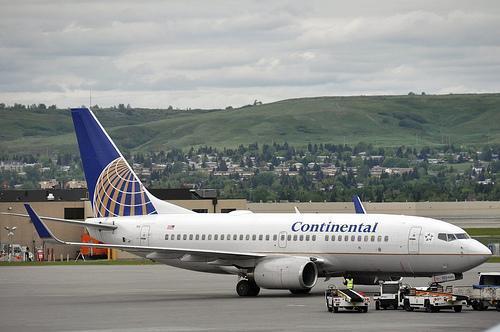How many people are in the photo?
Give a very brief answer. 1. 